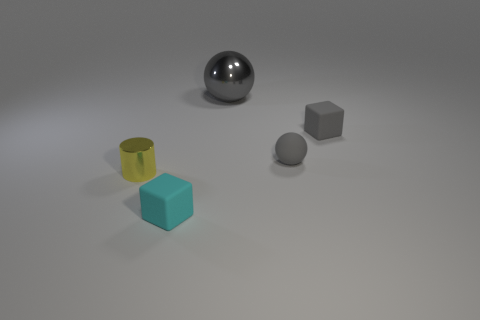Are there any other things that have the same size as the metallic ball?
Make the answer very short. No. What is the size of the matte thing that is left of the ball in front of the big gray metallic object?
Make the answer very short. Small. Is there anything else that is the same shape as the big object?
Your answer should be very brief. Yes. Is the number of small rubber blocks less than the number of objects?
Offer a very short reply. Yes. What material is the thing that is left of the gray matte sphere and behind the small yellow metal object?
Your response must be concise. Metal. Is there a large gray metal thing that is behind the metal thing in front of the large metal object?
Your answer should be very brief. Yes. What number of objects are big yellow rubber cubes or shiny objects?
Provide a succinct answer. 2. The thing that is to the left of the tiny gray matte sphere and to the right of the tiny cyan object has what shape?
Provide a short and direct response. Sphere. Do the tiny cube that is right of the cyan block and the small cyan object have the same material?
Ensure brevity in your answer.  Yes. What number of objects are big shiny balls or rubber objects that are behind the small yellow metal cylinder?
Provide a short and direct response. 3. 